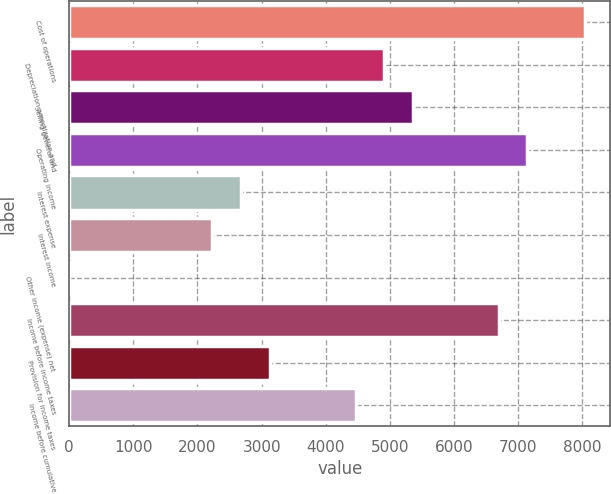Convert chart to OTSL. <chart><loc_0><loc_0><loc_500><loc_500><bar_chart><fcel>Cost of operations<fcel>Depreciation amortization and<fcel>Selling general and<fcel>Operating income<fcel>Interest expense<fcel>Interest income<fcel>Other income (expense) net<fcel>Income before income taxes<fcel>Provision for income taxes<fcel>Income before cumulative<nl><fcel>8035.32<fcel>4910.94<fcel>5357.28<fcel>7142.64<fcel>2679.24<fcel>2232.9<fcel>1.2<fcel>6696.3<fcel>3125.58<fcel>4464.6<nl></chart> 